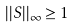<formula> <loc_0><loc_0><loc_500><loc_500>| | S | | _ { \infty } \geq 1</formula> 